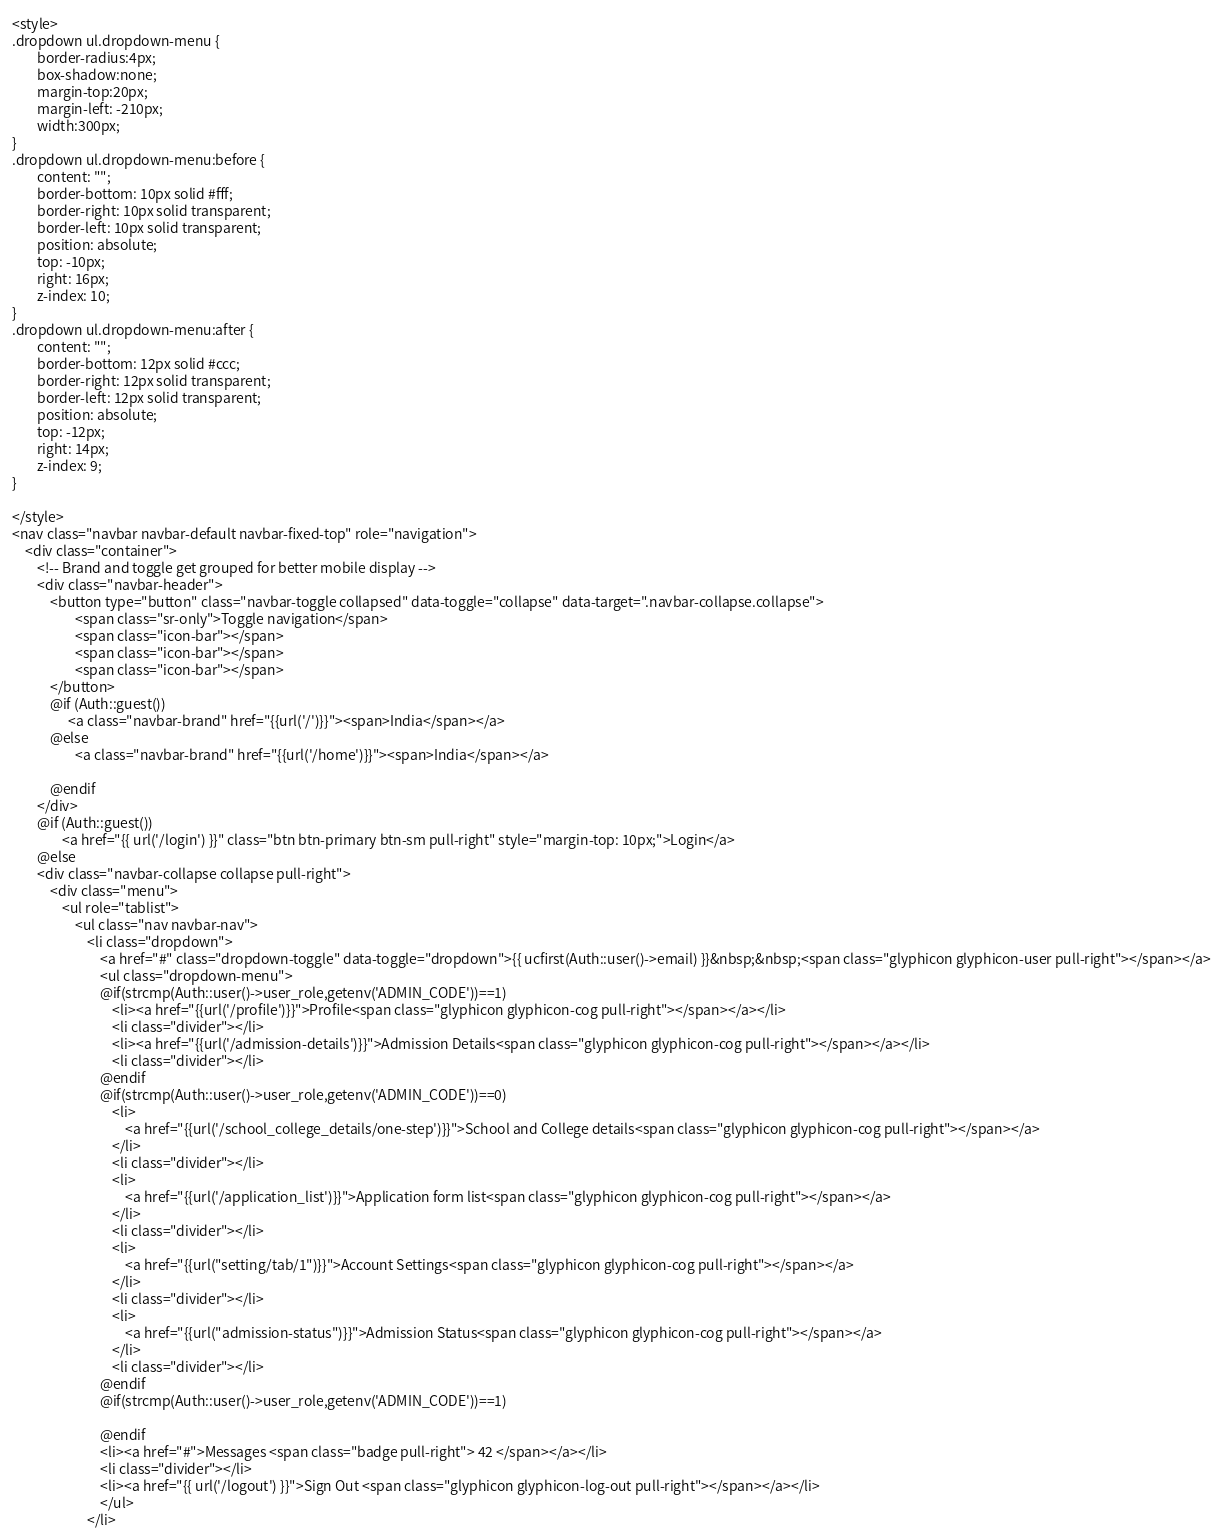<code> <loc_0><loc_0><loc_500><loc_500><_PHP_><style>
.dropdown ul.dropdown-menu {
        border-radius:4px;
        box-shadow:none;
        margin-top:20px;
        margin-left: -210px;
        width:300px;
}
.dropdown ul.dropdown-menu:before {
        content: "";
        border-bottom: 10px solid #fff;
        border-right: 10px solid transparent;
        border-left: 10px solid transparent;
        position: absolute;
        top: -10px;
        right: 16px;
        z-index: 10;
}
.dropdown ul.dropdown-menu:after {
        content: "";
        border-bottom: 12px solid #ccc;
        border-right: 12px solid transparent;
        border-left: 12px solid transparent;
        position: absolute;
        top: -12px;
        right: 14px;
        z-index: 9;
}	

</style>
<nav class="navbar navbar-default navbar-fixed-top" role="navigation">
    <div class="container">
        <!-- Brand and toggle get grouped for better mobile display -->
        <div class="navbar-header">
            <button type="button" class="navbar-toggle collapsed" data-toggle="collapse" data-target=".navbar-collapse.collapse">
                    <span class="sr-only">Toggle navigation</span>
                    <span class="icon-bar"></span>
                    <span class="icon-bar"></span>
                    <span class="icon-bar"></span>
            </button>                          
            @if (Auth::guest())
                  <a class="navbar-brand" href="{{url('/')}}"><span>India</span></a>
            @else               
                    <a class="navbar-brand" href="{{url('/home')}}"><span>India</span></a>
               
            @endif                                                       
        </div>
        @if (Auth::guest())
                <a href="{{ url('/login') }}" class="btn btn-primary btn-sm pull-right" style="margin-top: 10px;">Login</a>
        @else
        <div class="navbar-collapse collapse pull-right">
            <div class="menu">
                <ul role="tablist">
                    <ul class="nav navbar-nav">
                        <li class="dropdown">
                            <a href="#" class="dropdown-toggle" data-toggle="dropdown">{{ ucfirst(Auth::user()->email) }}&nbsp;&nbsp;<span class="glyphicon glyphicon-user pull-right"></span></a>
                            <ul class="dropdown-menu">
                            @if(strcmp(Auth::user()->user_role,getenv('ADMIN_CODE'))==1)
                                <li><a href="{{url('/profile')}}">Profile<span class="glyphicon glyphicon-cog pull-right"></span></a></li>
                                <li class="divider"></li>
                                <li><a href="{{url('/admission-details')}}">Admission Details<span class="glyphicon glyphicon-cog pull-right"></span></a></li>
                                <li class="divider"></li>
                            @endif
                            @if(strcmp(Auth::user()->user_role,getenv('ADMIN_CODE'))==0)
                                <li>
                                    <a href="{{url('/school_college_details/one-step')}}">School and College details<span class="glyphicon glyphicon-cog pull-right"></span></a>
                                </li>
                                <li class="divider"></li>
                                <li>
                                    <a href="{{url('/application_list')}}">Application form list<span class="glyphicon glyphicon-cog pull-right"></span></a>
                                </li>
                                <li class="divider"></li>
                                <li>
                                    <a href="{{url("setting/tab/1")}}">Account Settings<span class="glyphicon glyphicon-cog pull-right"></span></a>
                                </li>
                                <li class="divider"></li>
                                <li>
                                    <a href="{{url("admission-status")}}">Admission Status<span class="glyphicon glyphicon-cog pull-right"></span></a>
                                </li>
                                <li class="divider"></li>
                            @endif
                            @if(strcmp(Auth::user()->user_role,getenv('ADMIN_CODE'))==1)

                            @endif
                            <li><a href="#">Messages <span class="badge pull-right"> 42 </span></a></li>
                            <li class="divider"></li>
                            <li><a href="{{ url('/logout') }}">Sign Out <span class="glyphicon glyphicon-log-out pull-right"></span></a></li>
                            </ul>
                        </li></code> 